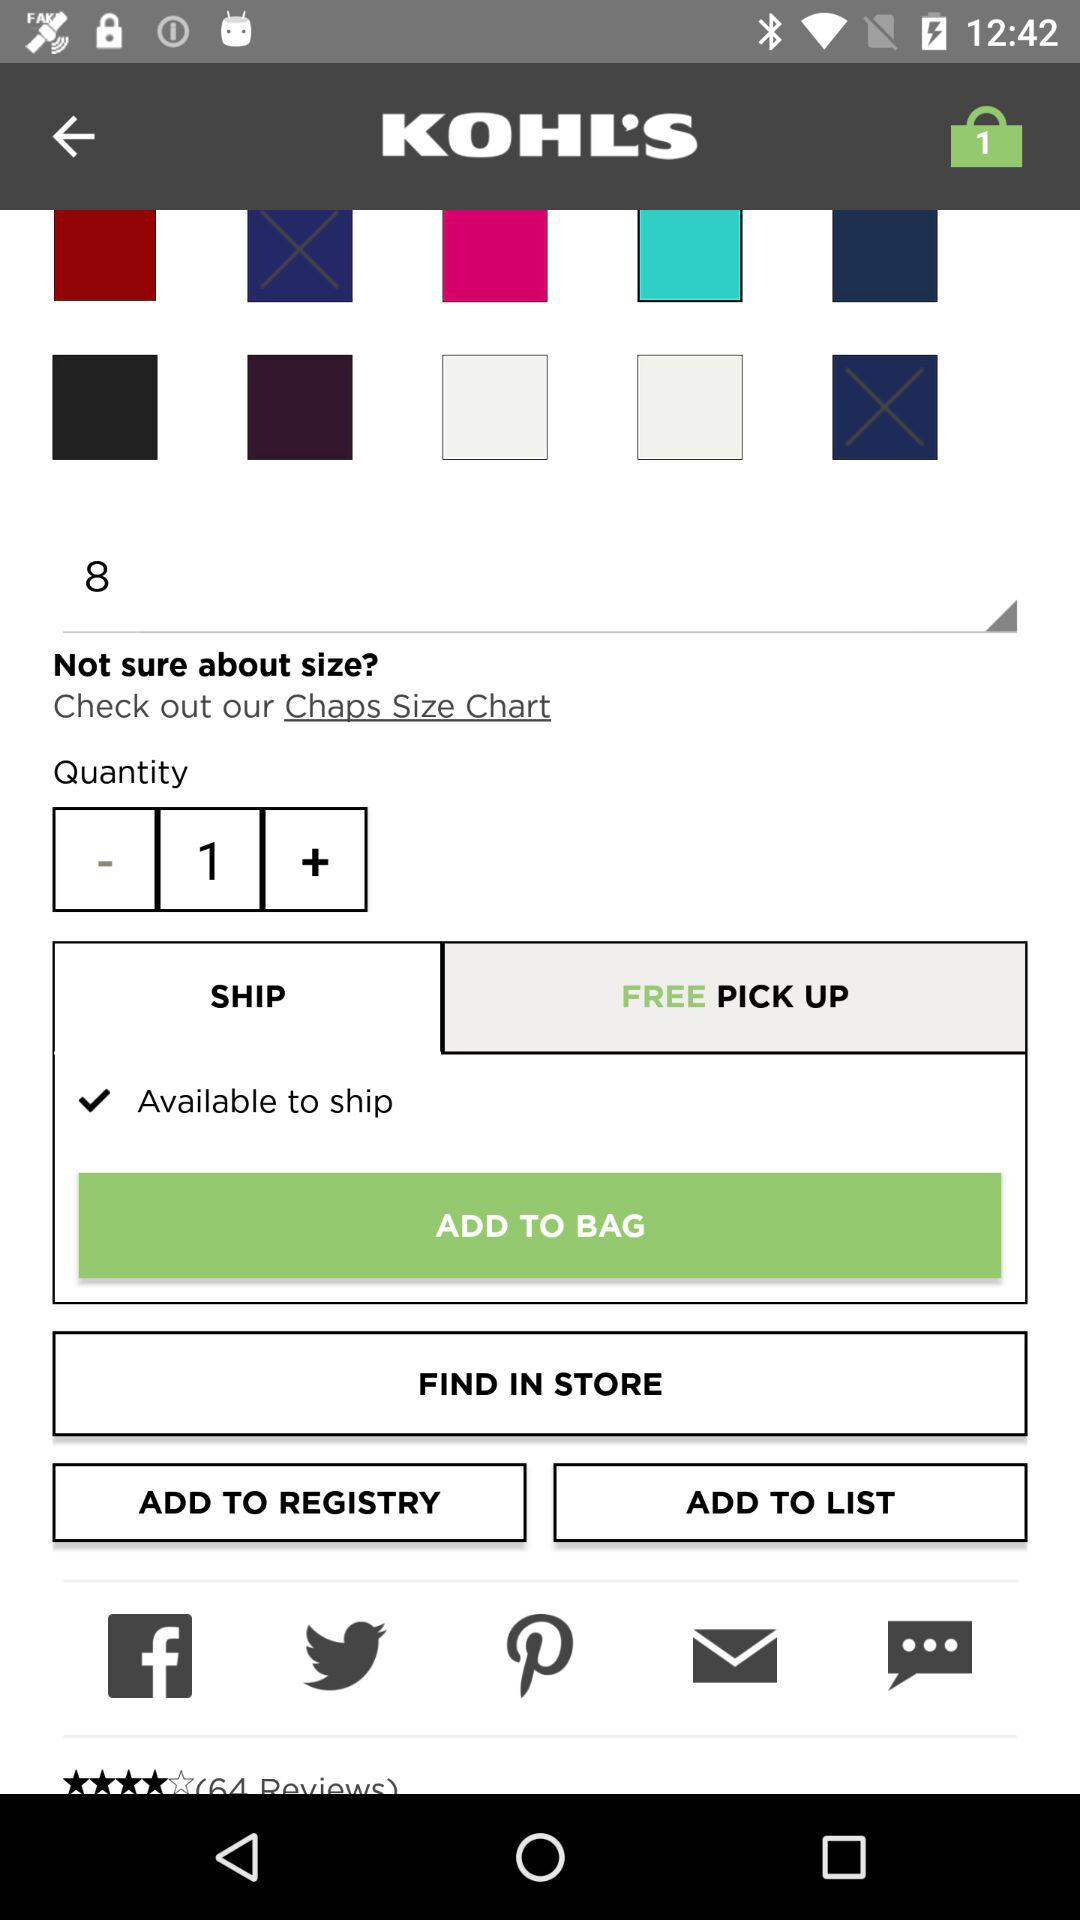What is the application name? The application name is "KOHL'S". 